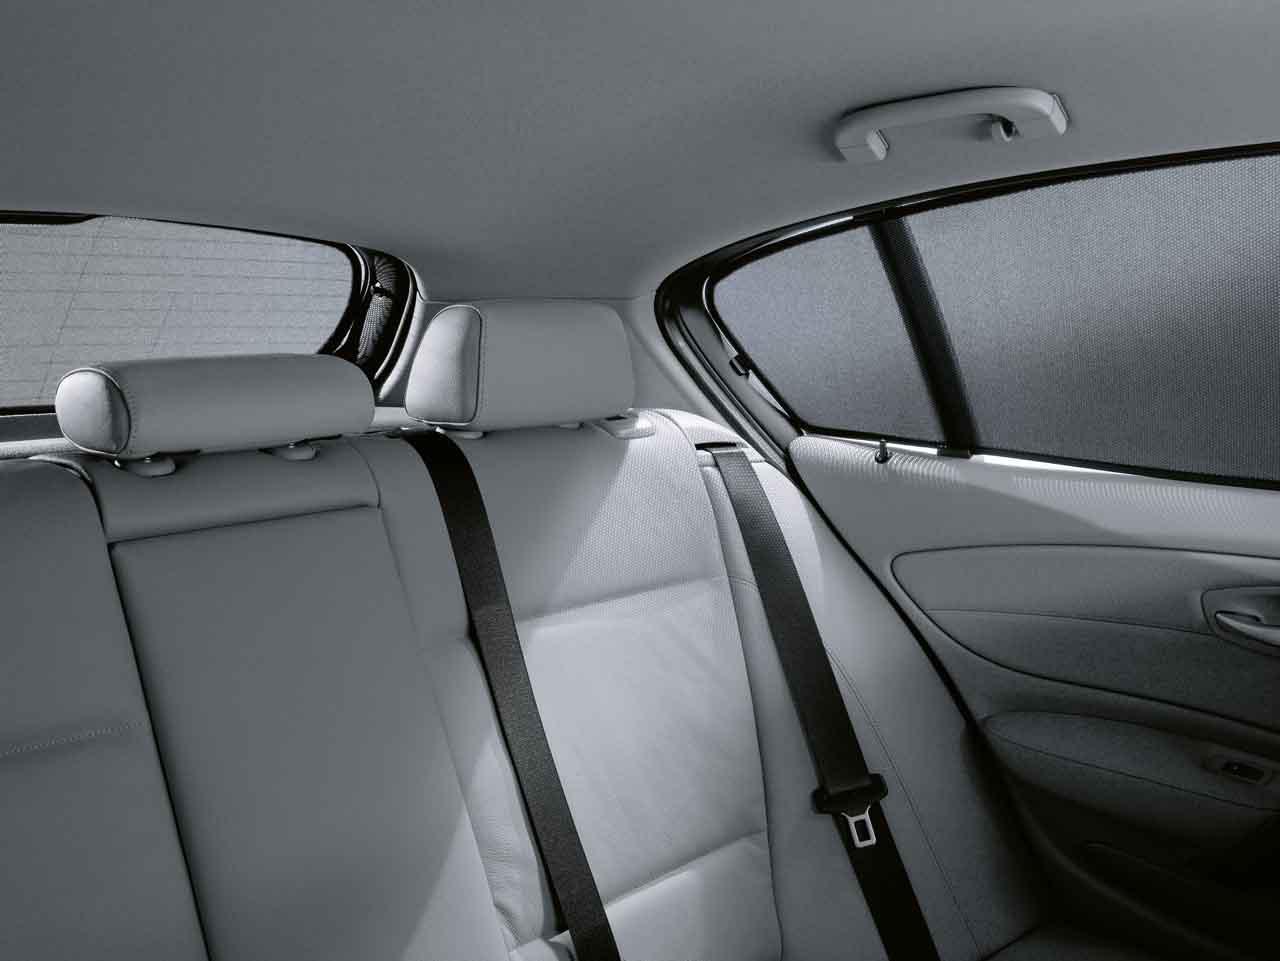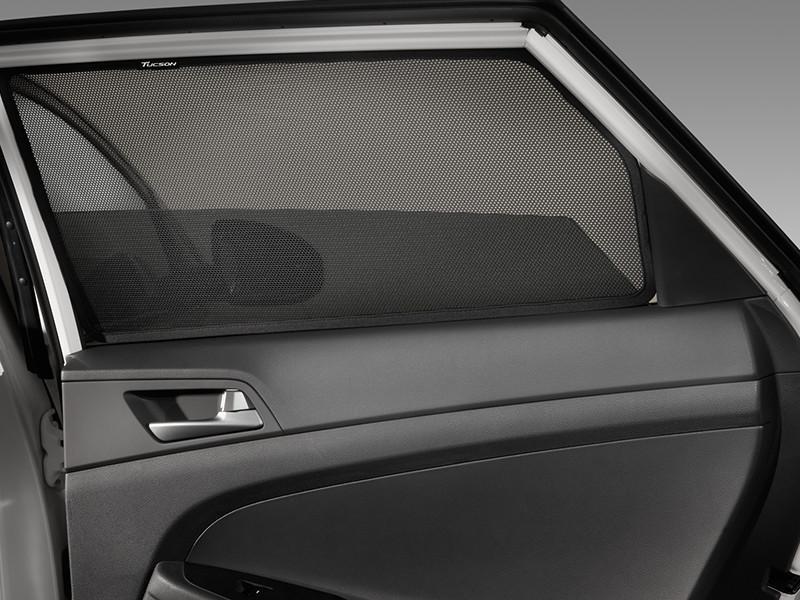The first image is the image on the left, the second image is the image on the right. Given the left and right images, does the statement "A human arm is visible on the right image." hold true? Answer yes or no. No. 